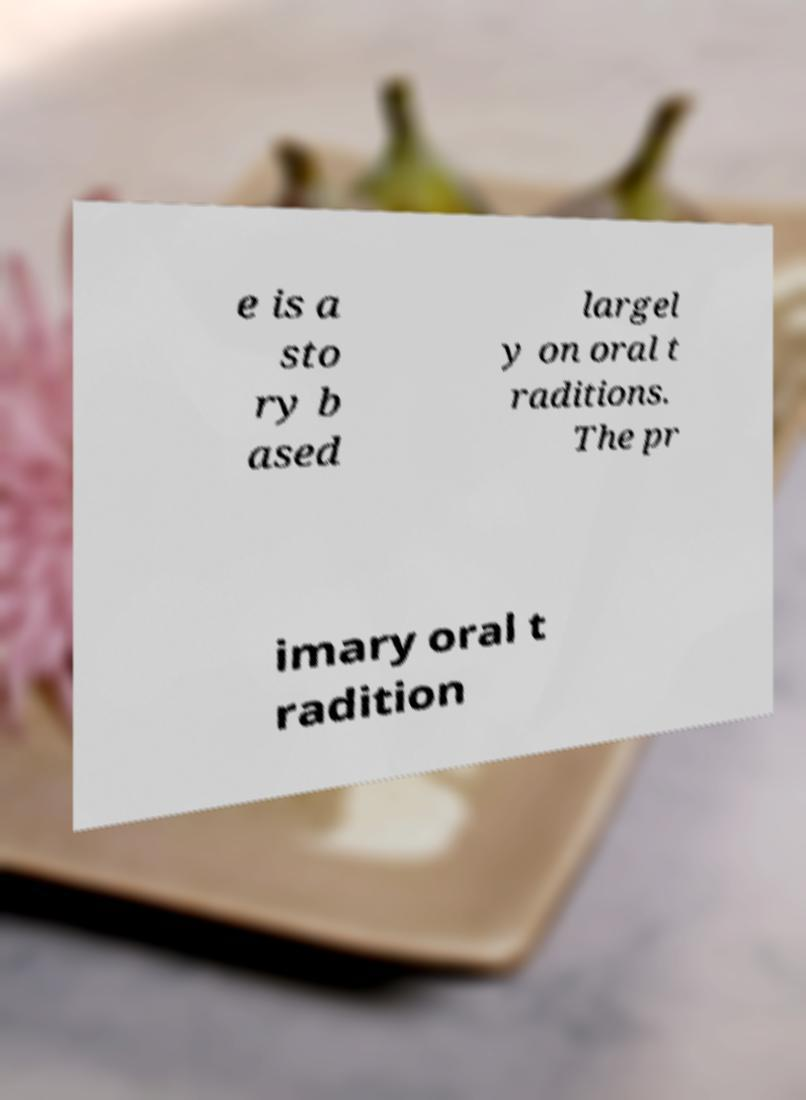For documentation purposes, I need the text within this image transcribed. Could you provide that? e is a sto ry b ased largel y on oral t raditions. The pr imary oral t radition 